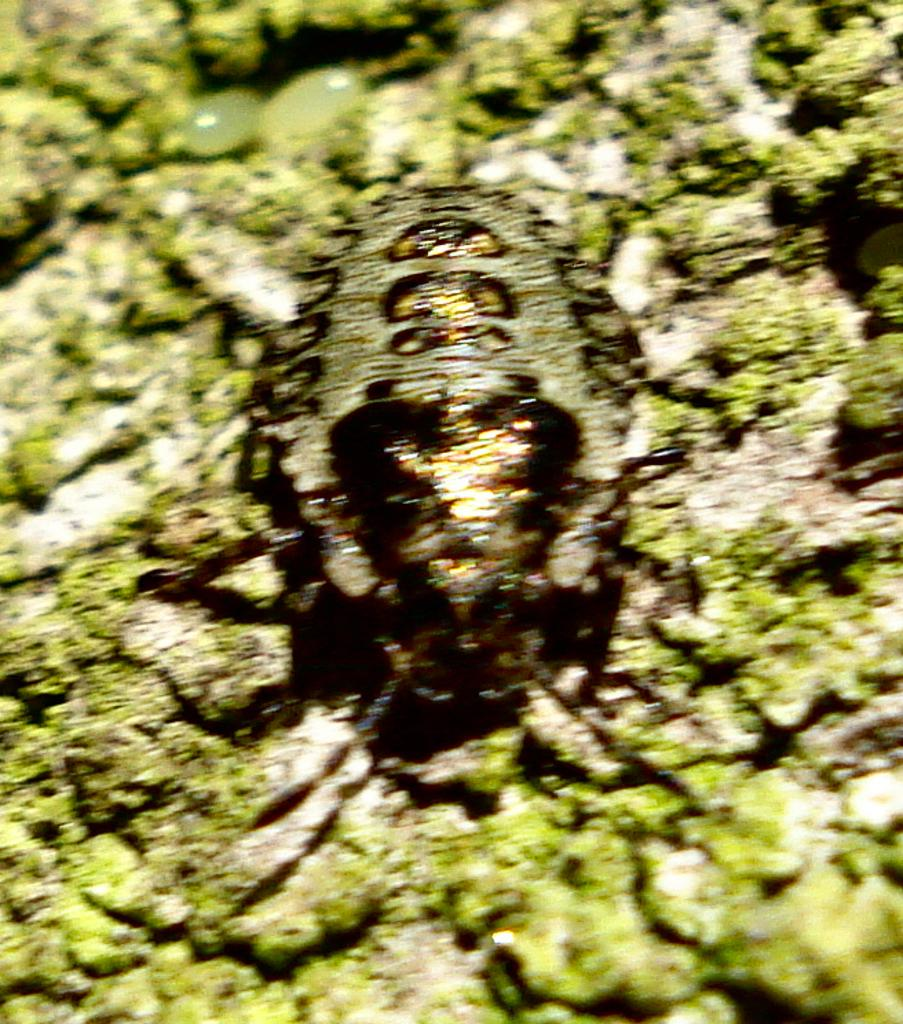What is the main subject in the center of the image? There is an insect in the center of the image. What can be seen at the bottom of the image? There are stones at the bottom of the image. What type of vegetation is present in the image? There is grass in the image. How many flies are visible in the image? There are no flies present in the image; it features an insect, but it is not specified as a fly. 